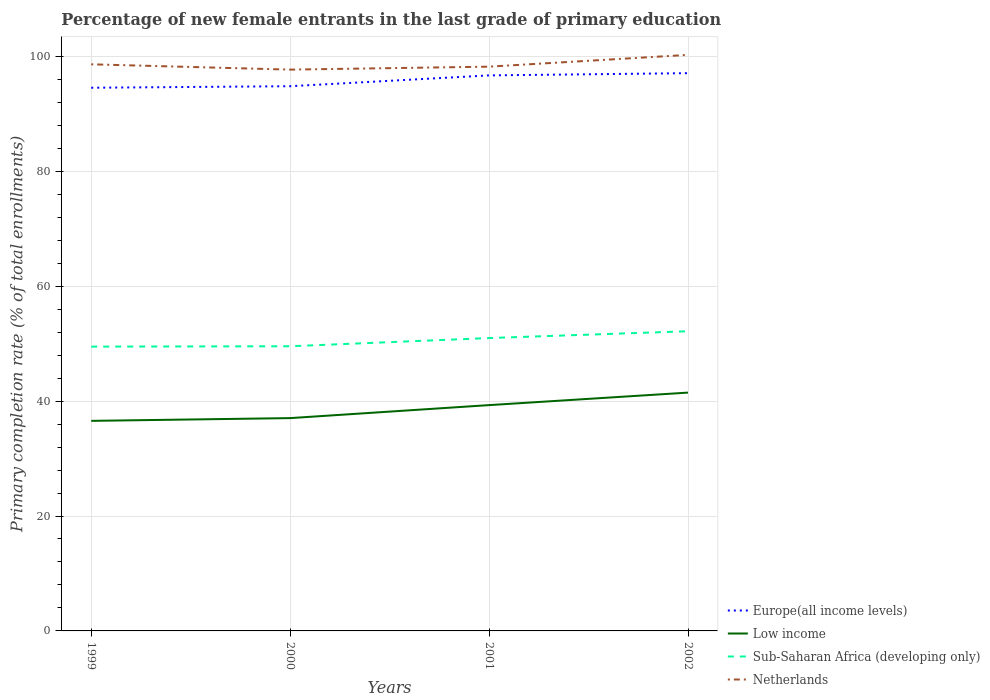Is the number of lines equal to the number of legend labels?
Make the answer very short. Yes. Across all years, what is the maximum percentage of new female entrants in Netherlands?
Provide a succinct answer. 97.7. What is the total percentage of new female entrants in Netherlands in the graph?
Provide a succinct answer. 0.92. What is the difference between the highest and the second highest percentage of new female entrants in Sub-Saharan Africa (developing only)?
Offer a terse response. 2.68. Is the percentage of new female entrants in Low income strictly greater than the percentage of new female entrants in Netherlands over the years?
Ensure brevity in your answer.  Yes. How many lines are there?
Your answer should be compact. 4. Does the graph contain any zero values?
Offer a very short reply. No. How are the legend labels stacked?
Provide a succinct answer. Vertical. What is the title of the graph?
Provide a succinct answer. Percentage of new female entrants in the last grade of primary education. What is the label or title of the X-axis?
Keep it short and to the point. Years. What is the label or title of the Y-axis?
Offer a very short reply. Primary completion rate (% of total enrollments). What is the Primary completion rate (% of total enrollments) in Europe(all income levels) in 1999?
Your answer should be compact. 94.55. What is the Primary completion rate (% of total enrollments) of Low income in 1999?
Provide a short and direct response. 36.56. What is the Primary completion rate (% of total enrollments) in Sub-Saharan Africa (developing only) in 1999?
Keep it short and to the point. 49.48. What is the Primary completion rate (% of total enrollments) in Netherlands in 1999?
Ensure brevity in your answer.  98.62. What is the Primary completion rate (% of total enrollments) of Europe(all income levels) in 2000?
Keep it short and to the point. 94.81. What is the Primary completion rate (% of total enrollments) in Low income in 2000?
Your answer should be compact. 37.04. What is the Primary completion rate (% of total enrollments) of Sub-Saharan Africa (developing only) in 2000?
Provide a succinct answer. 49.55. What is the Primary completion rate (% of total enrollments) in Netherlands in 2000?
Offer a terse response. 97.7. What is the Primary completion rate (% of total enrollments) in Europe(all income levels) in 2001?
Provide a succinct answer. 96.69. What is the Primary completion rate (% of total enrollments) in Low income in 2001?
Your response must be concise. 39.3. What is the Primary completion rate (% of total enrollments) of Sub-Saharan Africa (developing only) in 2001?
Offer a terse response. 50.98. What is the Primary completion rate (% of total enrollments) in Netherlands in 2001?
Provide a short and direct response. 98.21. What is the Primary completion rate (% of total enrollments) of Europe(all income levels) in 2002?
Your answer should be very brief. 97.08. What is the Primary completion rate (% of total enrollments) of Low income in 2002?
Offer a very short reply. 41.48. What is the Primary completion rate (% of total enrollments) in Sub-Saharan Africa (developing only) in 2002?
Give a very brief answer. 52.16. What is the Primary completion rate (% of total enrollments) of Netherlands in 2002?
Offer a terse response. 100.26. Across all years, what is the maximum Primary completion rate (% of total enrollments) in Europe(all income levels)?
Keep it short and to the point. 97.08. Across all years, what is the maximum Primary completion rate (% of total enrollments) in Low income?
Ensure brevity in your answer.  41.48. Across all years, what is the maximum Primary completion rate (% of total enrollments) in Sub-Saharan Africa (developing only)?
Make the answer very short. 52.16. Across all years, what is the maximum Primary completion rate (% of total enrollments) in Netherlands?
Keep it short and to the point. 100.26. Across all years, what is the minimum Primary completion rate (% of total enrollments) in Europe(all income levels)?
Your response must be concise. 94.55. Across all years, what is the minimum Primary completion rate (% of total enrollments) of Low income?
Ensure brevity in your answer.  36.56. Across all years, what is the minimum Primary completion rate (% of total enrollments) of Sub-Saharan Africa (developing only)?
Offer a terse response. 49.48. Across all years, what is the minimum Primary completion rate (% of total enrollments) in Netherlands?
Keep it short and to the point. 97.7. What is the total Primary completion rate (% of total enrollments) of Europe(all income levels) in the graph?
Ensure brevity in your answer.  383.13. What is the total Primary completion rate (% of total enrollments) in Low income in the graph?
Keep it short and to the point. 154.39. What is the total Primary completion rate (% of total enrollments) of Sub-Saharan Africa (developing only) in the graph?
Give a very brief answer. 202.17. What is the total Primary completion rate (% of total enrollments) in Netherlands in the graph?
Provide a short and direct response. 394.8. What is the difference between the Primary completion rate (% of total enrollments) of Europe(all income levels) in 1999 and that in 2000?
Provide a succinct answer. -0.26. What is the difference between the Primary completion rate (% of total enrollments) in Low income in 1999 and that in 2000?
Provide a short and direct response. -0.48. What is the difference between the Primary completion rate (% of total enrollments) of Sub-Saharan Africa (developing only) in 1999 and that in 2000?
Your response must be concise. -0.06. What is the difference between the Primary completion rate (% of total enrollments) of Netherlands in 1999 and that in 2000?
Provide a short and direct response. 0.92. What is the difference between the Primary completion rate (% of total enrollments) of Europe(all income levels) in 1999 and that in 2001?
Your answer should be very brief. -2.15. What is the difference between the Primary completion rate (% of total enrollments) of Low income in 1999 and that in 2001?
Provide a short and direct response. -2.74. What is the difference between the Primary completion rate (% of total enrollments) of Sub-Saharan Africa (developing only) in 1999 and that in 2001?
Make the answer very short. -1.49. What is the difference between the Primary completion rate (% of total enrollments) of Netherlands in 1999 and that in 2001?
Make the answer very short. 0.41. What is the difference between the Primary completion rate (% of total enrollments) of Europe(all income levels) in 1999 and that in 2002?
Give a very brief answer. -2.53. What is the difference between the Primary completion rate (% of total enrollments) of Low income in 1999 and that in 2002?
Provide a succinct answer. -4.92. What is the difference between the Primary completion rate (% of total enrollments) of Sub-Saharan Africa (developing only) in 1999 and that in 2002?
Your answer should be compact. -2.68. What is the difference between the Primary completion rate (% of total enrollments) of Netherlands in 1999 and that in 2002?
Make the answer very short. -1.64. What is the difference between the Primary completion rate (% of total enrollments) in Europe(all income levels) in 2000 and that in 2001?
Your response must be concise. -1.88. What is the difference between the Primary completion rate (% of total enrollments) in Low income in 2000 and that in 2001?
Offer a terse response. -2.26. What is the difference between the Primary completion rate (% of total enrollments) in Sub-Saharan Africa (developing only) in 2000 and that in 2001?
Give a very brief answer. -1.43. What is the difference between the Primary completion rate (% of total enrollments) of Netherlands in 2000 and that in 2001?
Your response must be concise. -0.52. What is the difference between the Primary completion rate (% of total enrollments) in Europe(all income levels) in 2000 and that in 2002?
Make the answer very short. -2.27. What is the difference between the Primary completion rate (% of total enrollments) of Low income in 2000 and that in 2002?
Provide a succinct answer. -4.44. What is the difference between the Primary completion rate (% of total enrollments) of Sub-Saharan Africa (developing only) in 2000 and that in 2002?
Give a very brief answer. -2.61. What is the difference between the Primary completion rate (% of total enrollments) of Netherlands in 2000 and that in 2002?
Your response must be concise. -2.57. What is the difference between the Primary completion rate (% of total enrollments) of Europe(all income levels) in 2001 and that in 2002?
Your answer should be compact. -0.39. What is the difference between the Primary completion rate (% of total enrollments) of Low income in 2001 and that in 2002?
Provide a succinct answer. -2.18. What is the difference between the Primary completion rate (% of total enrollments) of Sub-Saharan Africa (developing only) in 2001 and that in 2002?
Make the answer very short. -1.19. What is the difference between the Primary completion rate (% of total enrollments) of Netherlands in 2001 and that in 2002?
Provide a succinct answer. -2.05. What is the difference between the Primary completion rate (% of total enrollments) of Europe(all income levels) in 1999 and the Primary completion rate (% of total enrollments) of Low income in 2000?
Provide a short and direct response. 57.5. What is the difference between the Primary completion rate (% of total enrollments) of Europe(all income levels) in 1999 and the Primary completion rate (% of total enrollments) of Sub-Saharan Africa (developing only) in 2000?
Your response must be concise. 45. What is the difference between the Primary completion rate (% of total enrollments) in Europe(all income levels) in 1999 and the Primary completion rate (% of total enrollments) in Netherlands in 2000?
Keep it short and to the point. -3.15. What is the difference between the Primary completion rate (% of total enrollments) of Low income in 1999 and the Primary completion rate (% of total enrollments) of Sub-Saharan Africa (developing only) in 2000?
Offer a terse response. -12.99. What is the difference between the Primary completion rate (% of total enrollments) of Low income in 1999 and the Primary completion rate (% of total enrollments) of Netherlands in 2000?
Provide a succinct answer. -61.14. What is the difference between the Primary completion rate (% of total enrollments) of Sub-Saharan Africa (developing only) in 1999 and the Primary completion rate (% of total enrollments) of Netherlands in 2000?
Give a very brief answer. -48.21. What is the difference between the Primary completion rate (% of total enrollments) of Europe(all income levels) in 1999 and the Primary completion rate (% of total enrollments) of Low income in 2001?
Your answer should be compact. 55.24. What is the difference between the Primary completion rate (% of total enrollments) of Europe(all income levels) in 1999 and the Primary completion rate (% of total enrollments) of Sub-Saharan Africa (developing only) in 2001?
Offer a very short reply. 43.57. What is the difference between the Primary completion rate (% of total enrollments) in Europe(all income levels) in 1999 and the Primary completion rate (% of total enrollments) in Netherlands in 2001?
Your answer should be very brief. -3.67. What is the difference between the Primary completion rate (% of total enrollments) of Low income in 1999 and the Primary completion rate (% of total enrollments) of Sub-Saharan Africa (developing only) in 2001?
Your answer should be very brief. -14.41. What is the difference between the Primary completion rate (% of total enrollments) in Low income in 1999 and the Primary completion rate (% of total enrollments) in Netherlands in 2001?
Your answer should be compact. -61.65. What is the difference between the Primary completion rate (% of total enrollments) of Sub-Saharan Africa (developing only) in 1999 and the Primary completion rate (% of total enrollments) of Netherlands in 2001?
Keep it short and to the point. -48.73. What is the difference between the Primary completion rate (% of total enrollments) of Europe(all income levels) in 1999 and the Primary completion rate (% of total enrollments) of Low income in 2002?
Provide a succinct answer. 53.06. What is the difference between the Primary completion rate (% of total enrollments) in Europe(all income levels) in 1999 and the Primary completion rate (% of total enrollments) in Sub-Saharan Africa (developing only) in 2002?
Offer a very short reply. 42.38. What is the difference between the Primary completion rate (% of total enrollments) in Europe(all income levels) in 1999 and the Primary completion rate (% of total enrollments) in Netherlands in 2002?
Offer a very short reply. -5.72. What is the difference between the Primary completion rate (% of total enrollments) in Low income in 1999 and the Primary completion rate (% of total enrollments) in Sub-Saharan Africa (developing only) in 2002?
Your response must be concise. -15.6. What is the difference between the Primary completion rate (% of total enrollments) of Low income in 1999 and the Primary completion rate (% of total enrollments) of Netherlands in 2002?
Keep it short and to the point. -63.7. What is the difference between the Primary completion rate (% of total enrollments) of Sub-Saharan Africa (developing only) in 1999 and the Primary completion rate (% of total enrollments) of Netherlands in 2002?
Offer a terse response. -50.78. What is the difference between the Primary completion rate (% of total enrollments) of Europe(all income levels) in 2000 and the Primary completion rate (% of total enrollments) of Low income in 2001?
Your answer should be very brief. 55.51. What is the difference between the Primary completion rate (% of total enrollments) of Europe(all income levels) in 2000 and the Primary completion rate (% of total enrollments) of Sub-Saharan Africa (developing only) in 2001?
Provide a short and direct response. 43.83. What is the difference between the Primary completion rate (% of total enrollments) in Europe(all income levels) in 2000 and the Primary completion rate (% of total enrollments) in Netherlands in 2001?
Provide a short and direct response. -3.4. What is the difference between the Primary completion rate (% of total enrollments) of Low income in 2000 and the Primary completion rate (% of total enrollments) of Sub-Saharan Africa (developing only) in 2001?
Provide a succinct answer. -13.94. What is the difference between the Primary completion rate (% of total enrollments) of Low income in 2000 and the Primary completion rate (% of total enrollments) of Netherlands in 2001?
Give a very brief answer. -61.17. What is the difference between the Primary completion rate (% of total enrollments) of Sub-Saharan Africa (developing only) in 2000 and the Primary completion rate (% of total enrollments) of Netherlands in 2001?
Ensure brevity in your answer.  -48.66. What is the difference between the Primary completion rate (% of total enrollments) of Europe(all income levels) in 2000 and the Primary completion rate (% of total enrollments) of Low income in 2002?
Offer a very short reply. 53.33. What is the difference between the Primary completion rate (% of total enrollments) of Europe(all income levels) in 2000 and the Primary completion rate (% of total enrollments) of Sub-Saharan Africa (developing only) in 2002?
Give a very brief answer. 42.65. What is the difference between the Primary completion rate (% of total enrollments) of Europe(all income levels) in 2000 and the Primary completion rate (% of total enrollments) of Netherlands in 2002?
Make the answer very short. -5.45. What is the difference between the Primary completion rate (% of total enrollments) in Low income in 2000 and the Primary completion rate (% of total enrollments) in Sub-Saharan Africa (developing only) in 2002?
Your response must be concise. -15.12. What is the difference between the Primary completion rate (% of total enrollments) of Low income in 2000 and the Primary completion rate (% of total enrollments) of Netherlands in 2002?
Keep it short and to the point. -63.22. What is the difference between the Primary completion rate (% of total enrollments) in Sub-Saharan Africa (developing only) in 2000 and the Primary completion rate (% of total enrollments) in Netherlands in 2002?
Provide a succinct answer. -50.72. What is the difference between the Primary completion rate (% of total enrollments) in Europe(all income levels) in 2001 and the Primary completion rate (% of total enrollments) in Low income in 2002?
Your answer should be very brief. 55.21. What is the difference between the Primary completion rate (% of total enrollments) of Europe(all income levels) in 2001 and the Primary completion rate (% of total enrollments) of Sub-Saharan Africa (developing only) in 2002?
Offer a terse response. 44.53. What is the difference between the Primary completion rate (% of total enrollments) of Europe(all income levels) in 2001 and the Primary completion rate (% of total enrollments) of Netherlands in 2002?
Your answer should be very brief. -3.57. What is the difference between the Primary completion rate (% of total enrollments) in Low income in 2001 and the Primary completion rate (% of total enrollments) in Sub-Saharan Africa (developing only) in 2002?
Provide a short and direct response. -12.86. What is the difference between the Primary completion rate (% of total enrollments) of Low income in 2001 and the Primary completion rate (% of total enrollments) of Netherlands in 2002?
Provide a succinct answer. -60.96. What is the difference between the Primary completion rate (% of total enrollments) of Sub-Saharan Africa (developing only) in 2001 and the Primary completion rate (% of total enrollments) of Netherlands in 2002?
Offer a very short reply. -49.29. What is the average Primary completion rate (% of total enrollments) of Europe(all income levels) per year?
Provide a short and direct response. 95.78. What is the average Primary completion rate (% of total enrollments) in Low income per year?
Offer a very short reply. 38.6. What is the average Primary completion rate (% of total enrollments) of Sub-Saharan Africa (developing only) per year?
Your answer should be very brief. 50.54. What is the average Primary completion rate (% of total enrollments) in Netherlands per year?
Give a very brief answer. 98.7. In the year 1999, what is the difference between the Primary completion rate (% of total enrollments) of Europe(all income levels) and Primary completion rate (% of total enrollments) of Low income?
Offer a very short reply. 57.98. In the year 1999, what is the difference between the Primary completion rate (% of total enrollments) of Europe(all income levels) and Primary completion rate (% of total enrollments) of Sub-Saharan Africa (developing only)?
Offer a very short reply. 45.06. In the year 1999, what is the difference between the Primary completion rate (% of total enrollments) of Europe(all income levels) and Primary completion rate (% of total enrollments) of Netherlands?
Your response must be concise. -4.08. In the year 1999, what is the difference between the Primary completion rate (% of total enrollments) in Low income and Primary completion rate (% of total enrollments) in Sub-Saharan Africa (developing only)?
Ensure brevity in your answer.  -12.92. In the year 1999, what is the difference between the Primary completion rate (% of total enrollments) in Low income and Primary completion rate (% of total enrollments) in Netherlands?
Make the answer very short. -62.06. In the year 1999, what is the difference between the Primary completion rate (% of total enrollments) of Sub-Saharan Africa (developing only) and Primary completion rate (% of total enrollments) of Netherlands?
Your answer should be very brief. -49.14. In the year 2000, what is the difference between the Primary completion rate (% of total enrollments) in Europe(all income levels) and Primary completion rate (% of total enrollments) in Low income?
Your answer should be very brief. 57.77. In the year 2000, what is the difference between the Primary completion rate (% of total enrollments) of Europe(all income levels) and Primary completion rate (% of total enrollments) of Sub-Saharan Africa (developing only)?
Your answer should be compact. 45.26. In the year 2000, what is the difference between the Primary completion rate (% of total enrollments) of Europe(all income levels) and Primary completion rate (% of total enrollments) of Netherlands?
Provide a short and direct response. -2.89. In the year 2000, what is the difference between the Primary completion rate (% of total enrollments) in Low income and Primary completion rate (% of total enrollments) in Sub-Saharan Africa (developing only)?
Provide a succinct answer. -12.51. In the year 2000, what is the difference between the Primary completion rate (% of total enrollments) in Low income and Primary completion rate (% of total enrollments) in Netherlands?
Keep it short and to the point. -60.66. In the year 2000, what is the difference between the Primary completion rate (% of total enrollments) of Sub-Saharan Africa (developing only) and Primary completion rate (% of total enrollments) of Netherlands?
Keep it short and to the point. -48.15. In the year 2001, what is the difference between the Primary completion rate (% of total enrollments) in Europe(all income levels) and Primary completion rate (% of total enrollments) in Low income?
Ensure brevity in your answer.  57.39. In the year 2001, what is the difference between the Primary completion rate (% of total enrollments) in Europe(all income levels) and Primary completion rate (% of total enrollments) in Sub-Saharan Africa (developing only)?
Your answer should be compact. 45.72. In the year 2001, what is the difference between the Primary completion rate (% of total enrollments) of Europe(all income levels) and Primary completion rate (% of total enrollments) of Netherlands?
Your answer should be compact. -1.52. In the year 2001, what is the difference between the Primary completion rate (% of total enrollments) in Low income and Primary completion rate (% of total enrollments) in Sub-Saharan Africa (developing only)?
Keep it short and to the point. -11.67. In the year 2001, what is the difference between the Primary completion rate (% of total enrollments) of Low income and Primary completion rate (% of total enrollments) of Netherlands?
Ensure brevity in your answer.  -58.91. In the year 2001, what is the difference between the Primary completion rate (% of total enrollments) of Sub-Saharan Africa (developing only) and Primary completion rate (% of total enrollments) of Netherlands?
Your answer should be very brief. -47.24. In the year 2002, what is the difference between the Primary completion rate (% of total enrollments) in Europe(all income levels) and Primary completion rate (% of total enrollments) in Low income?
Offer a very short reply. 55.6. In the year 2002, what is the difference between the Primary completion rate (% of total enrollments) in Europe(all income levels) and Primary completion rate (% of total enrollments) in Sub-Saharan Africa (developing only)?
Offer a very short reply. 44.92. In the year 2002, what is the difference between the Primary completion rate (% of total enrollments) of Europe(all income levels) and Primary completion rate (% of total enrollments) of Netherlands?
Provide a short and direct response. -3.18. In the year 2002, what is the difference between the Primary completion rate (% of total enrollments) of Low income and Primary completion rate (% of total enrollments) of Sub-Saharan Africa (developing only)?
Ensure brevity in your answer.  -10.68. In the year 2002, what is the difference between the Primary completion rate (% of total enrollments) of Low income and Primary completion rate (% of total enrollments) of Netherlands?
Your answer should be compact. -58.78. In the year 2002, what is the difference between the Primary completion rate (% of total enrollments) of Sub-Saharan Africa (developing only) and Primary completion rate (% of total enrollments) of Netherlands?
Ensure brevity in your answer.  -48.1. What is the ratio of the Primary completion rate (% of total enrollments) in Europe(all income levels) in 1999 to that in 2000?
Provide a short and direct response. 1. What is the ratio of the Primary completion rate (% of total enrollments) in Low income in 1999 to that in 2000?
Your answer should be very brief. 0.99. What is the ratio of the Primary completion rate (% of total enrollments) of Netherlands in 1999 to that in 2000?
Your answer should be very brief. 1.01. What is the ratio of the Primary completion rate (% of total enrollments) of Europe(all income levels) in 1999 to that in 2001?
Offer a terse response. 0.98. What is the ratio of the Primary completion rate (% of total enrollments) of Low income in 1999 to that in 2001?
Provide a succinct answer. 0.93. What is the ratio of the Primary completion rate (% of total enrollments) in Sub-Saharan Africa (developing only) in 1999 to that in 2001?
Make the answer very short. 0.97. What is the ratio of the Primary completion rate (% of total enrollments) of Netherlands in 1999 to that in 2001?
Your answer should be very brief. 1. What is the ratio of the Primary completion rate (% of total enrollments) of Europe(all income levels) in 1999 to that in 2002?
Give a very brief answer. 0.97. What is the ratio of the Primary completion rate (% of total enrollments) in Low income in 1999 to that in 2002?
Give a very brief answer. 0.88. What is the ratio of the Primary completion rate (% of total enrollments) in Sub-Saharan Africa (developing only) in 1999 to that in 2002?
Your answer should be compact. 0.95. What is the ratio of the Primary completion rate (% of total enrollments) in Netherlands in 1999 to that in 2002?
Ensure brevity in your answer.  0.98. What is the ratio of the Primary completion rate (% of total enrollments) in Europe(all income levels) in 2000 to that in 2001?
Offer a very short reply. 0.98. What is the ratio of the Primary completion rate (% of total enrollments) of Low income in 2000 to that in 2001?
Provide a succinct answer. 0.94. What is the ratio of the Primary completion rate (% of total enrollments) in Netherlands in 2000 to that in 2001?
Your answer should be very brief. 0.99. What is the ratio of the Primary completion rate (% of total enrollments) in Europe(all income levels) in 2000 to that in 2002?
Offer a terse response. 0.98. What is the ratio of the Primary completion rate (% of total enrollments) in Low income in 2000 to that in 2002?
Offer a terse response. 0.89. What is the ratio of the Primary completion rate (% of total enrollments) of Sub-Saharan Africa (developing only) in 2000 to that in 2002?
Your response must be concise. 0.95. What is the ratio of the Primary completion rate (% of total enrollments) in Netherlands in 2000 to that in 2002?
Your answer should be compact. 0.97. What is the ratio of the Primary completion rate (% of total enrollments) of Low income in 2001 to that in 2002?
Give a very brief answer. 0.95. What is the ratio of the Primary completion rate (% of total enrollments) in Sub-Saharan Africa (developing only) in 2001 to that in 2002?
Your answer should be compact. 0.98. What is the ratio of the Primary completion rate (% of total enrollments) in Netherlands in 2001 to that in 2002?
Ensure brevity in your answer.  0.98. What is the difference between the highest and the second highest Primary completion rate (% of total enrollments) in Europe(all income levels)?
Ensure brevity in your answer.  0.39. What is the difference between the highest and the second highest Primary completion rate (% of total enrollments) of Low income?
Offer a terse response. 2.18. What is the difference between the highest and the second highest Primary completion rate (% of total enrollments) in Sub-Saharan Africa (developing only)?
Your response must be concise. 1.19. What is the difference between the highest and the second highest Primary completion rate (% of total enrollments) of Netherlands?
Keep it short and to the point. 1.64. What is the difference between the highest and the lowest Primary completion rate (% of total enrollments) of Europe(all income levels)?
Your response must be concise. 2.53. What is the difference between the highest and the lowest Primary completion rate (% of total enrollments) of Low income?
Provide a succinct answer. 4.92. What is the difference between the highest and the lowest Primary completion rate (% of total enrollments) in Sub-Saharan Africa (developing only)?
Your answer should be very brief. 2.68. What is the difference between the highest and the lowest Primary completion rate (% of total enrollments) in Netherlands?
Give a very brief answer. 2.57. 